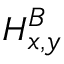Convert formula to latex. <formula><loc_0><loc_0><loc_500><loc_500>H _ { x , y } ^ { B }</formula> 